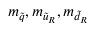<formula> <loc_0><loc_0><loc_500><loc_500>m _ { \tilde { q } } , m _ { { \tilde { u } } _ { R } } , m _ { { \tilde { d } } _ { R } }</formula> 